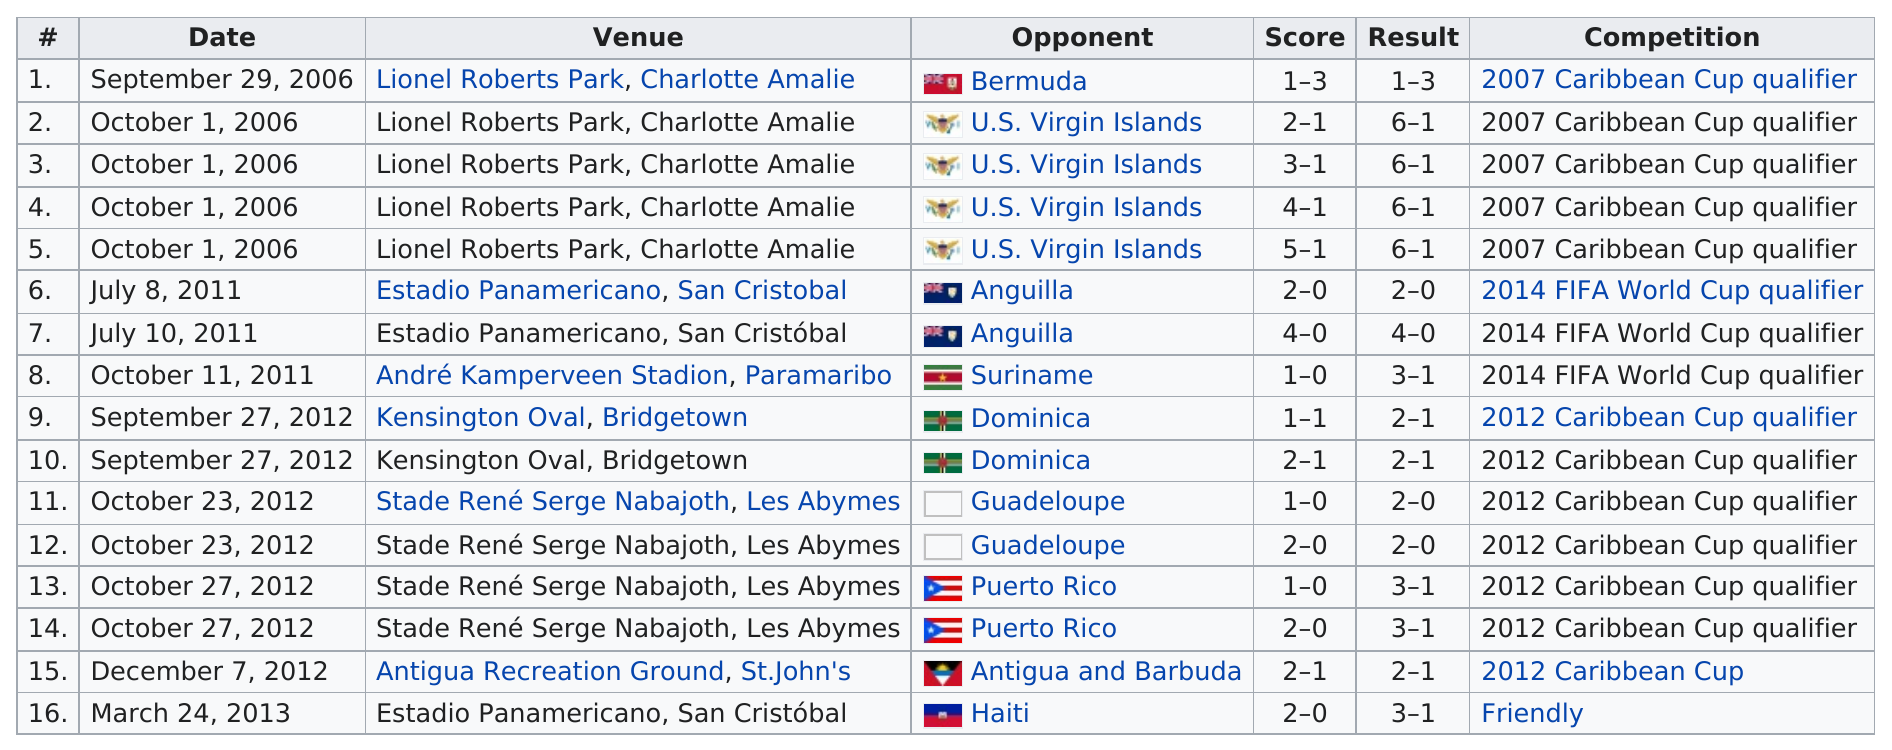Indicate a few pertinent items in this graphic. Their opponent, the United States Virgin Islands, was the fourth team they faced. It is more probable that they played at Lionel Roberts Park than at Andre Kamperveen Stadium, according to the information provided. The opponent won the match against Guadeloupe two times. On December 7, 2012, the date that is shown before March 24, 2013, is December 7, 2012. After facing the U.S. Virgin Islands in October 2006, this person played against Anguilla. 